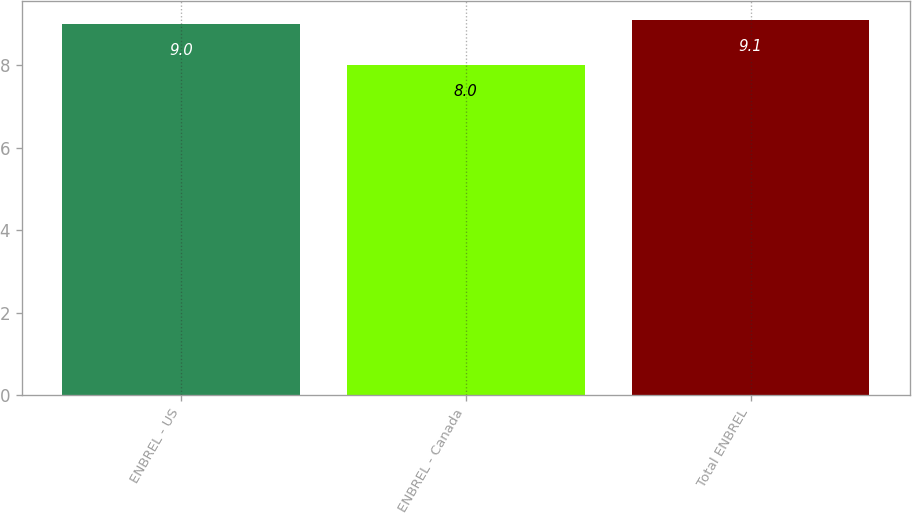<chart> <loc_0><loc_0><loc_500><loc_500><bar_chart><fcel>ENBREL - US<fcel>ENBREL - Canada<fcel>Total ENBREL<nl><fcel>9<fcel>8<fcel>9.1<nl></chart> 